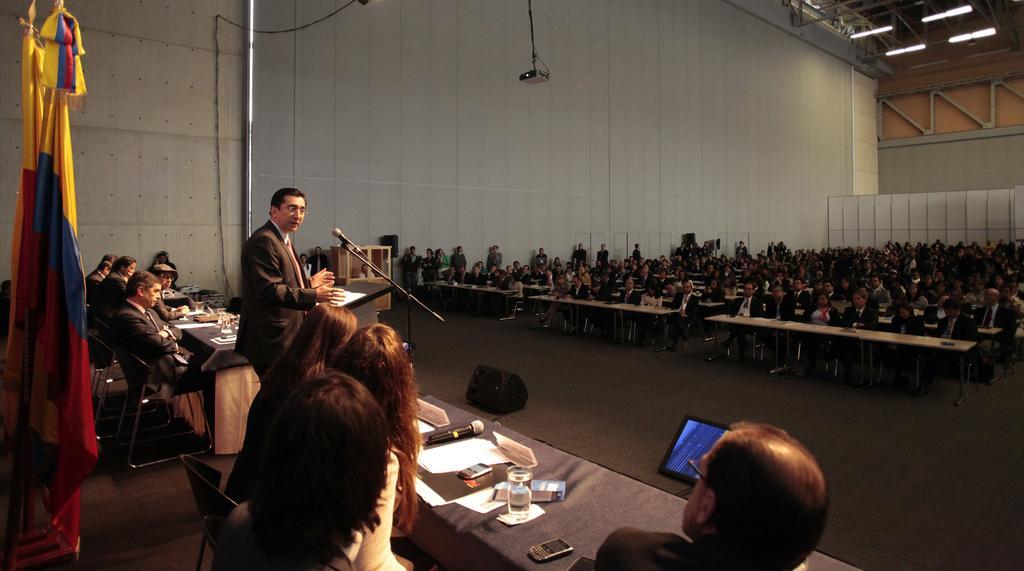How would you summarize this image in a sentence or two? On the left side of the image we can see one stage. On the stage, we can see one person standing and few people are sitting on the chairs. In front of them, we can see tables, one stand, microphone, speaker, monitor, etc. On the tables, we can see the papers, glasses, banners, microphones, mobile phones and a few other objects. And back of them, we can see two flags. In the background there is a wall, tables, chairs, few people are sitting and few other objects. 